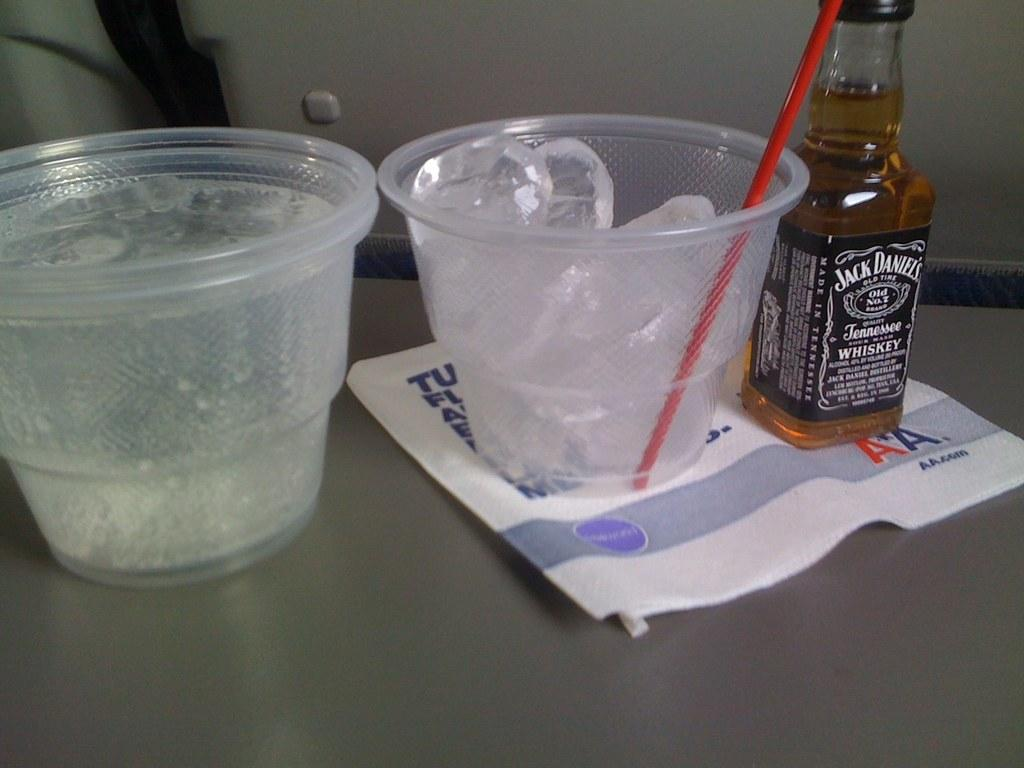<image>
Give a short and clear explanation of the subsequent image. A small bottle of Jack Daniels sits beside a small cup with only ice and another cup filled with clear liquid. 